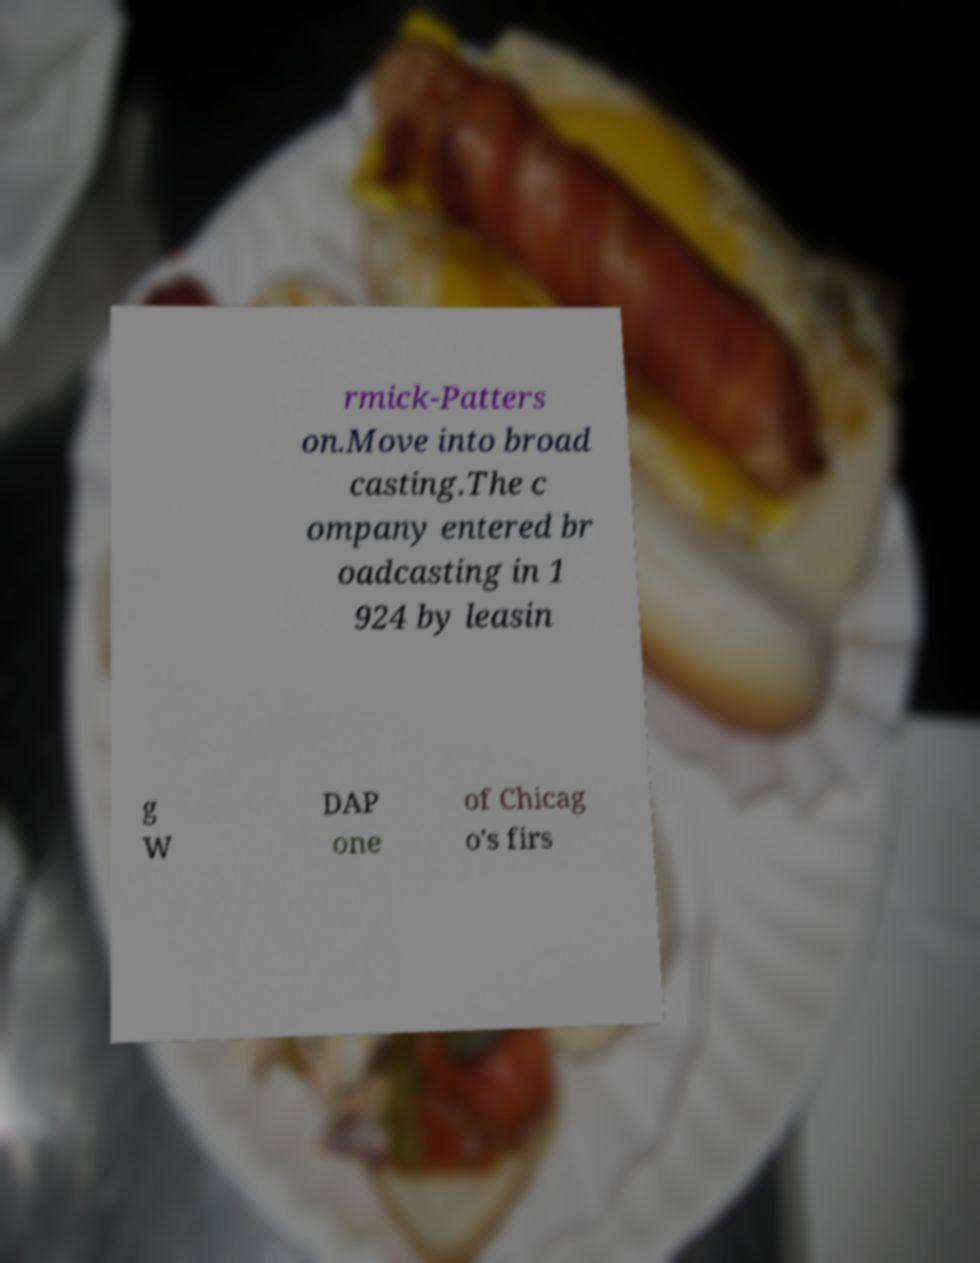Could you extract and type out the text from this image? rmick-Patters on.Move into broad casting.The c ompany entered br oadcasting in 1 924 by leasin g W DAP one of Chicag o's firs 